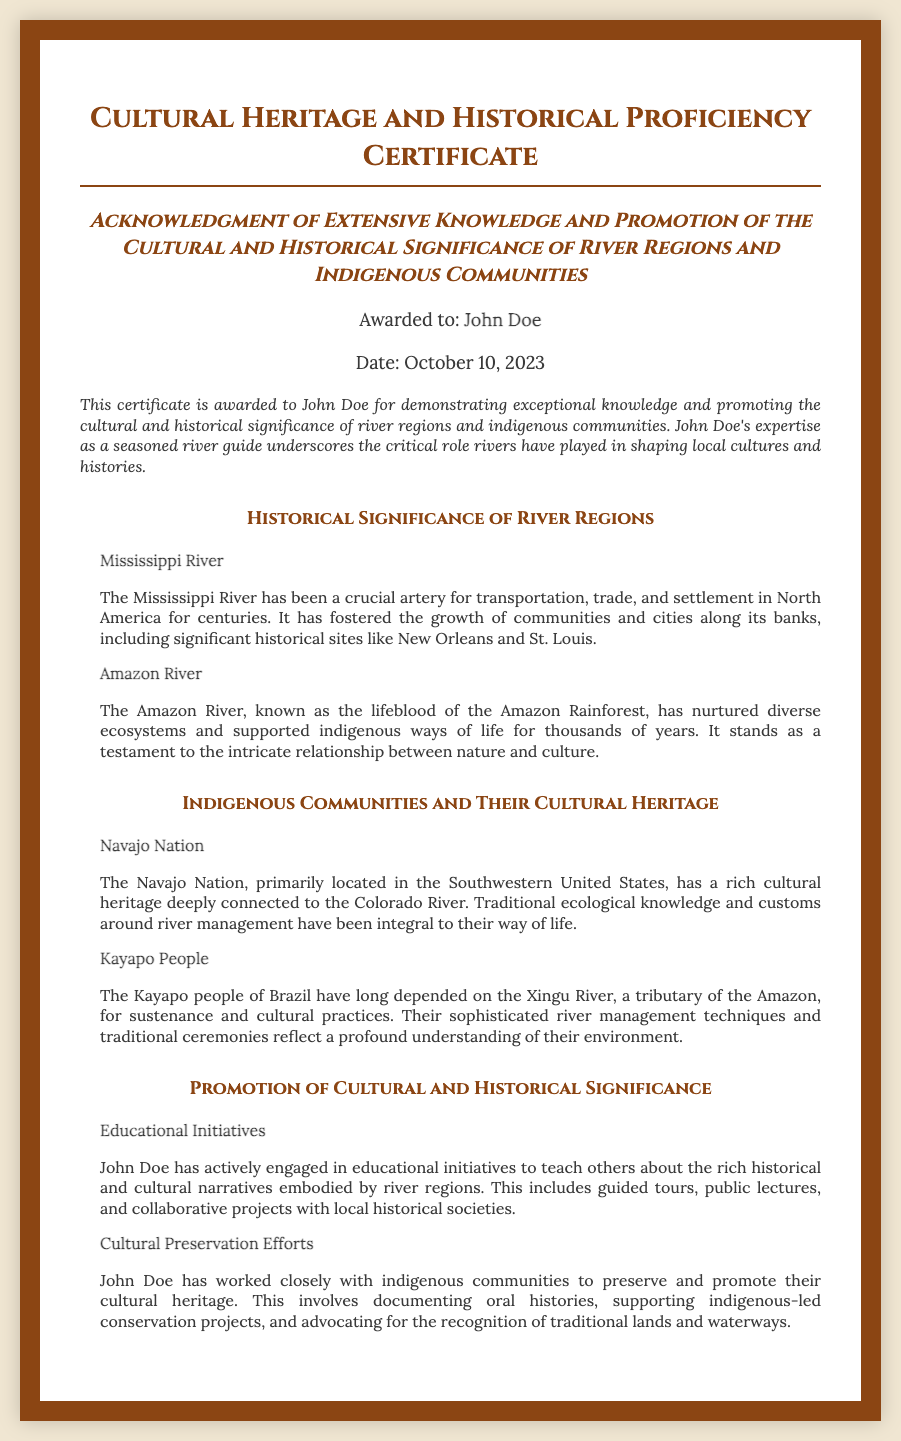what is the title of the certificate? The title of the certificate is presented at the top of the document in a prominent manner.
Answer: Cultural Heritage and Historical Proficiency Certificate who is awarded the certificate? The recipient's name is clearly stated in a designated area of the document.
Answer: John Doe when was the certificate awarded? The date is specified below the recipient's name, indicating when the certificate was given.
Answer: October 10, 2023 which river is associated with the Navajo Nation? The heading under the section about indigenous communities indicates the river related to their heritage.
Answer: Colorado River what initiative has John Doe engaged in to promote cultural significance? The document mentions specific actions taken by John Doe that relate to education and cultural promotion.
Answer: Educational Initiatives what is the significance of the Amazon River as stated in the certificate? The document highlights the role of the Amazon River in nurturing diverse ecosystems and supporting communities.
Answer: Lifeblood of the Amazon Rainforest how does John Doe contribute to cultural preservation? The document describes John's involvement in maintaining the historical narratives and customs of indigenous communities.
Answer: Documenting oral histories what historical site is mentioned in conjunction with the Mississippi River? The document lists specific locations that have historical importance tied to the river.
Answer: New Orleans which indigenous group is mentioned in relation to the Xingu River? This is stated in the section that discusses communities dependent on specific rivers.
Answer: Kayapo People 